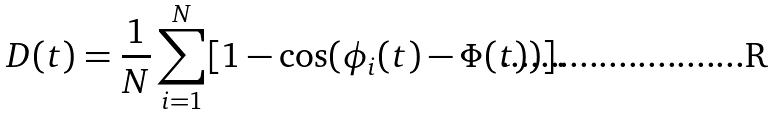<formula> <loc_0><loc_0><loc_500><loc_500>D ( t ) = \frac { 1 } { N } \sum _ { i = 1 } ^ { N } [ 1 - \cos ( \phi _ { i } ( t ) - \Phi ( t ) ) ] .</formula> 